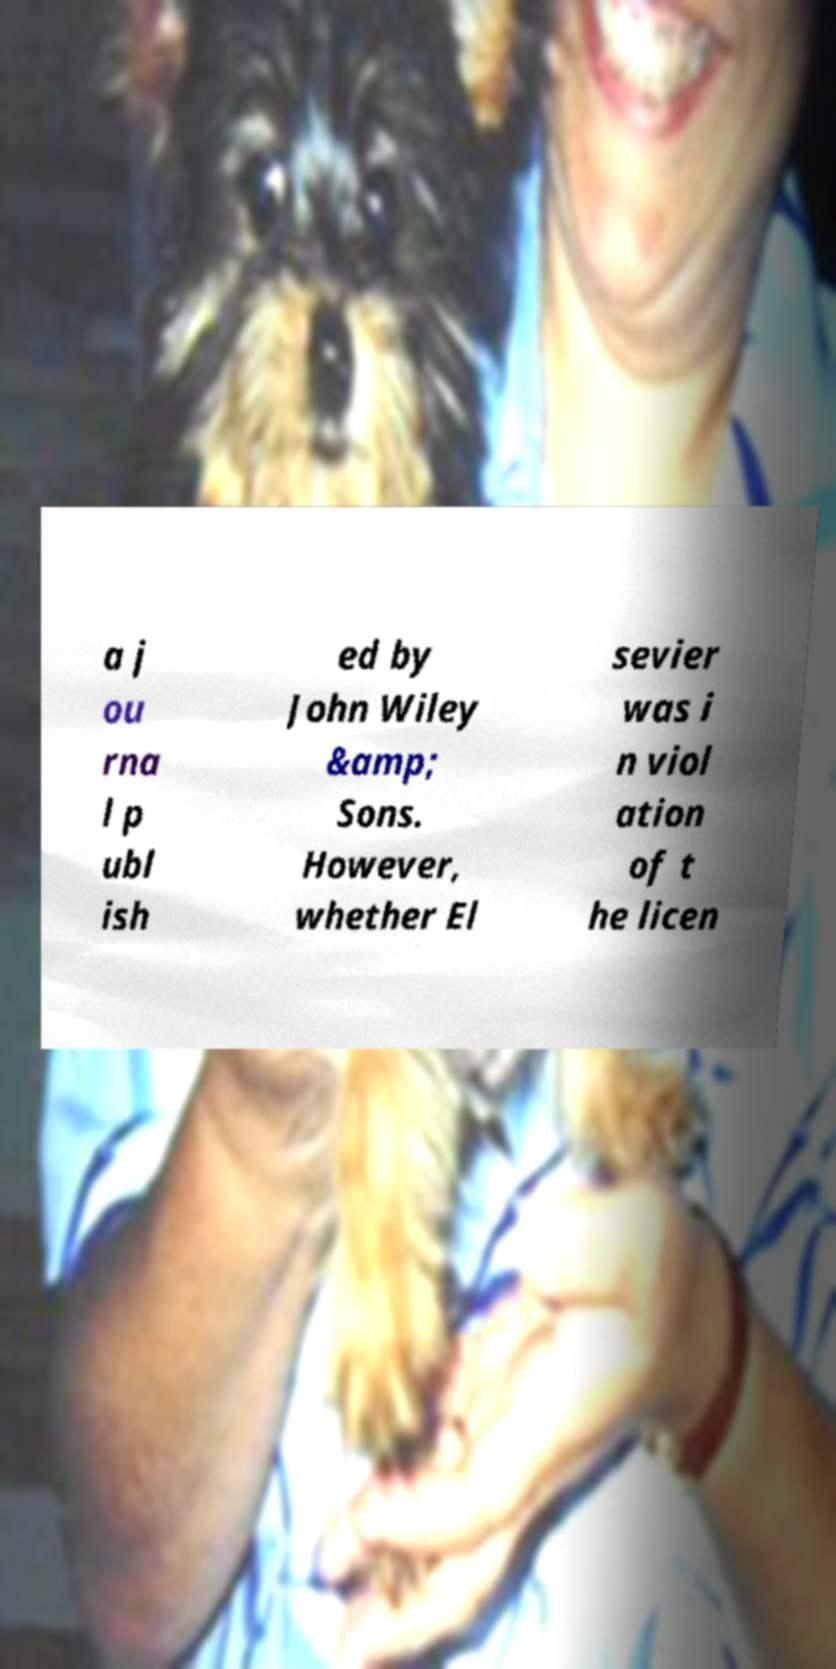I need the written content from this picture converted into text. Can you do that? a j ou rna l p ubl ish ed by John Wiley &amp; Sons. However, whether El sevier was i n viol ation of t he licen 